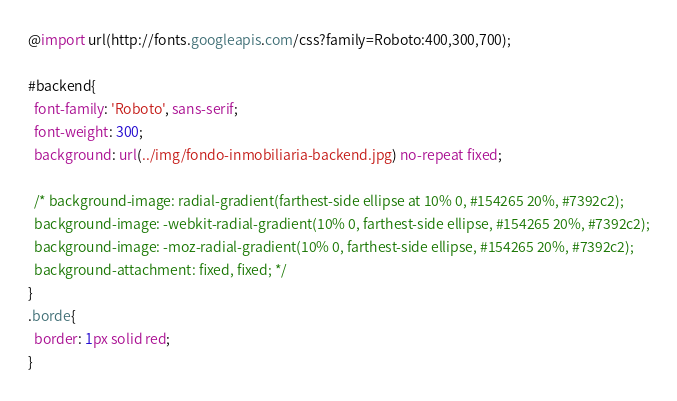Convert code to text. <code><loc_0><loc_0><loc_500><loc_500><_CSS_>@import url(http://fonts.googleapis.com/css?family=Roboto:400,300,700);

#backend{
  font-family: 'Roboto', sans-serif;
  font-weight: 300;
  background: url(../img/fondo-inmobiliaria-backend.jpg) no-repeat fixed;

  /* background-image: radial-gradient(farthest-side ellipse at 10% 0, #154265 20%, #7392c2);
  background-image: -webkit-radial-gradient(10% 0, farthest-side ellipse, #154265 20%, #7392c2);
  background-image: -moz-radial-gradient(10% 0, farthest-side ellipse, #154265 20%, #7392c2);
  background-attachment: fixed, fixed; */
}
.borde{
  border: 1px solid red;
}</code> 